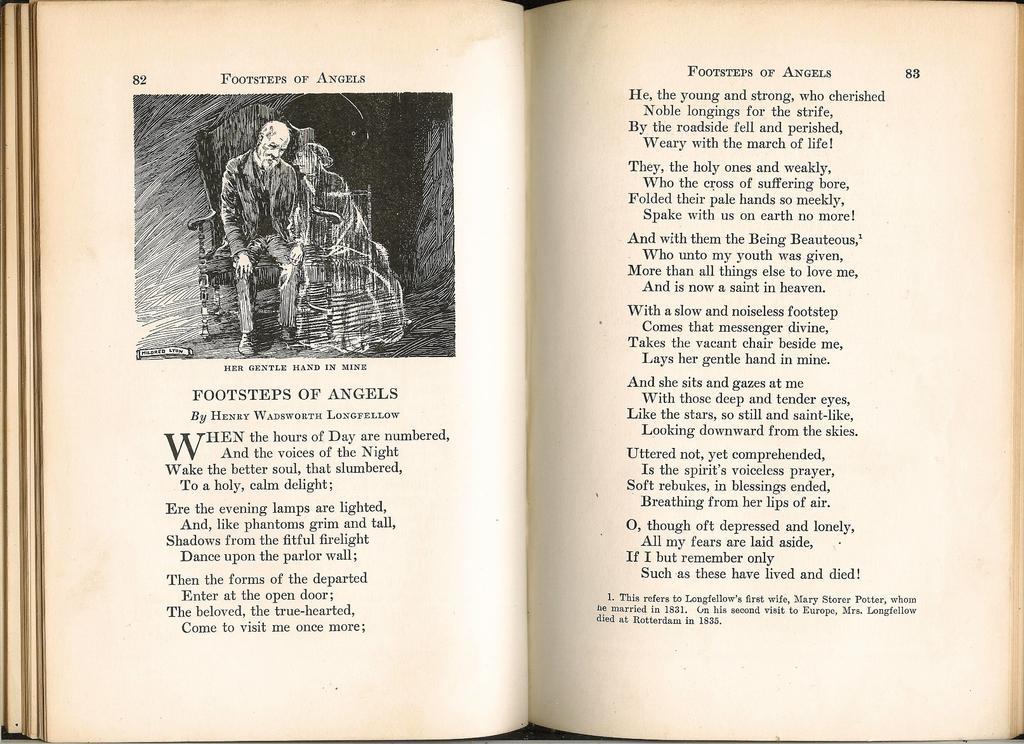Please provide a concise description of this image. In this picture we can see a book. In this book, we can see two people are sitting on the chair. 